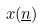<formula> <loc_0><loc_0><loc_500><loc_500>x ( \underline { n } )</formula> 